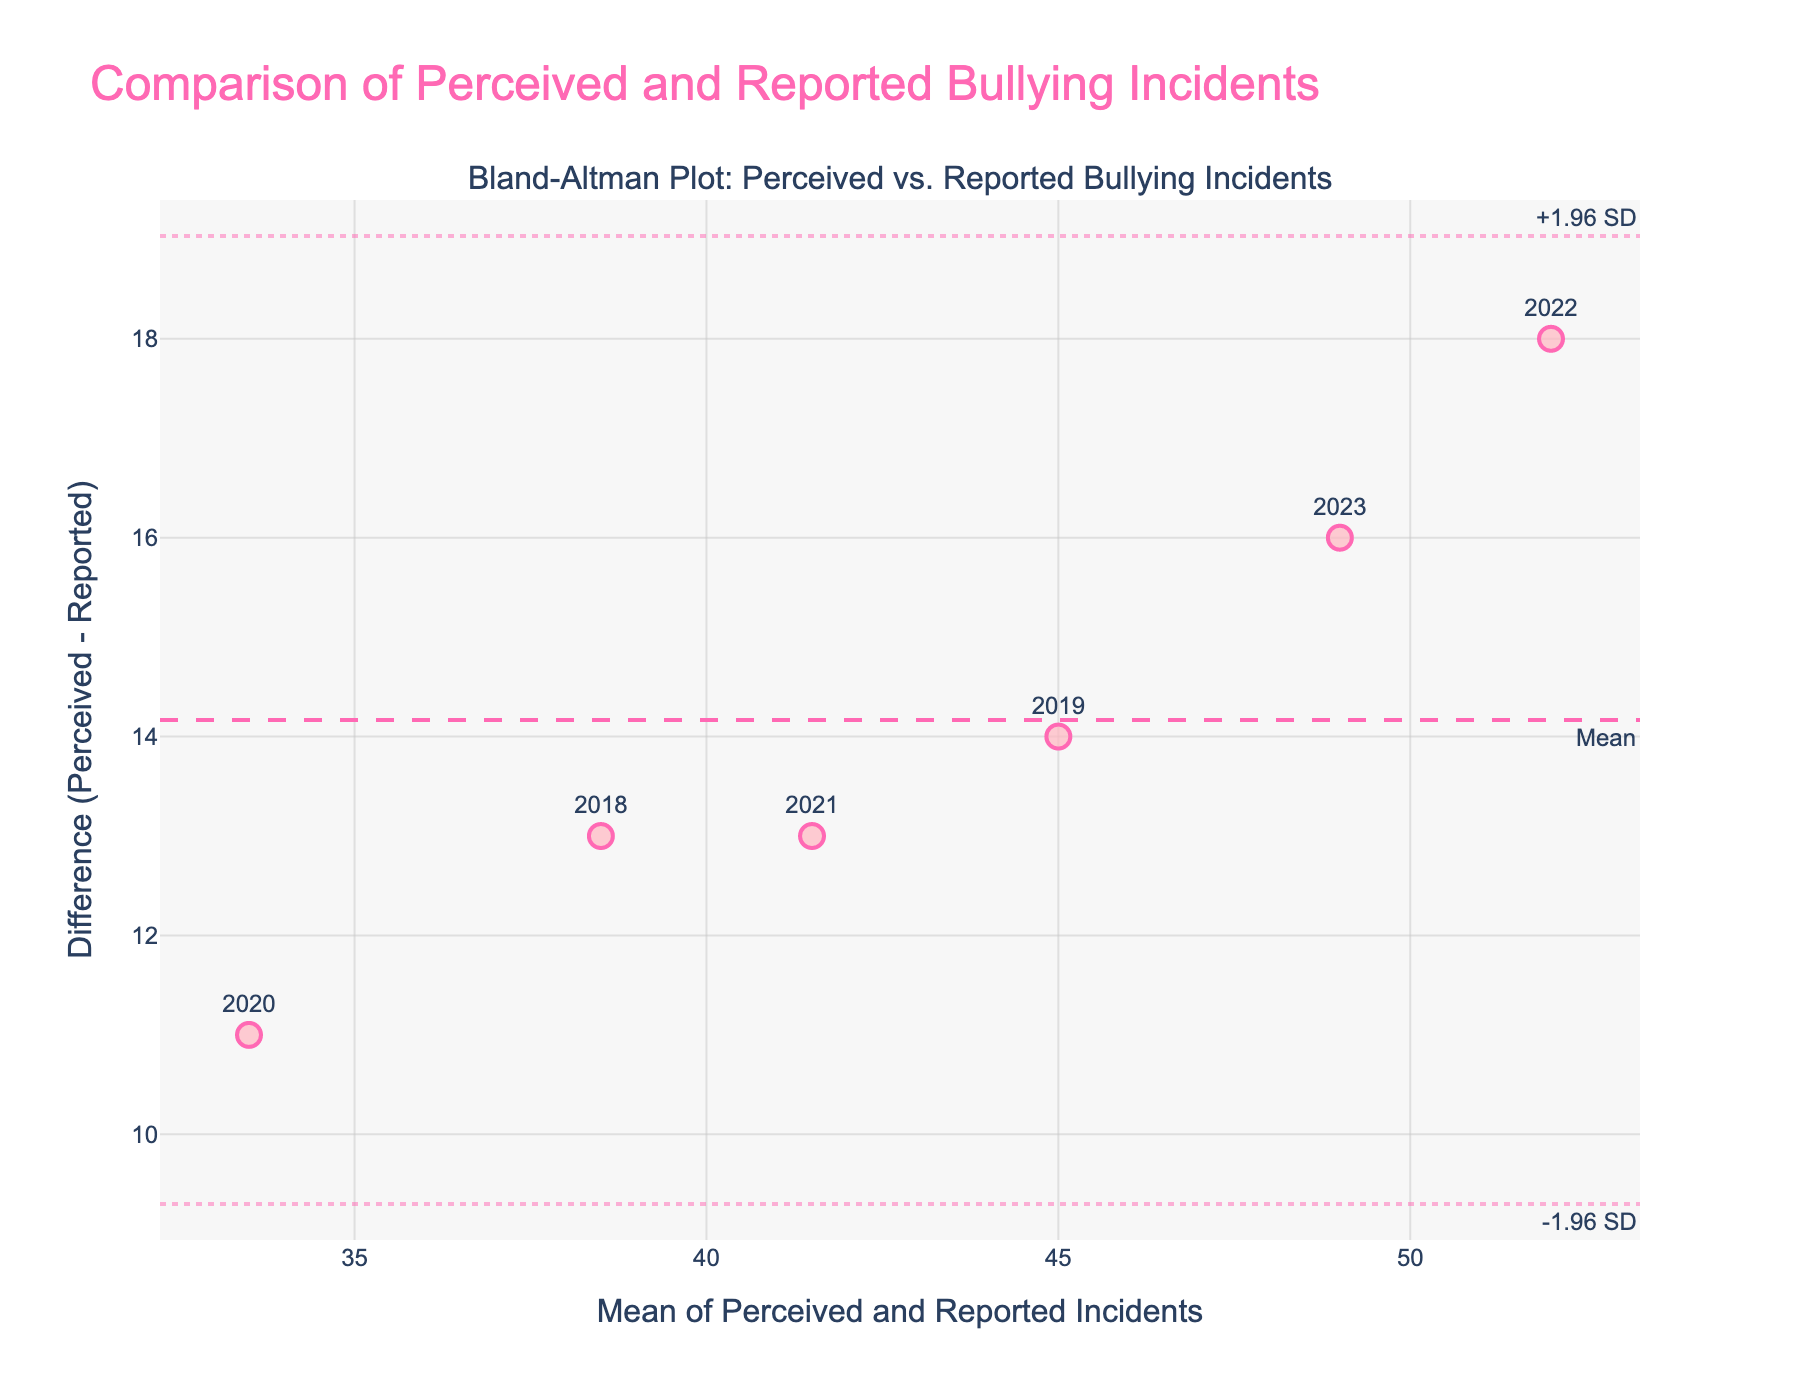How many data points are there on the Bland-Altman plot? There are six data points, one for each school year from 2018 to 2023.
Answer: 6 What is the title of the plot? The title of the plot is located at the top and reads, "Comparison of Perceived and Reported Bullying Incidents".
Answer: Comparison of Perceived and Reported Bullying Incidents What does the x-axis represent in the plot? The x-axis represents the "Mean of Perceived and Reported Incidents".
Answer: Mean of Perceived and Reported Incidents What is the difference between Student_Perceived and Officially_Reported incidents for the year 2022? For 2022, Student_Perceived is 61 and Officially_Reported is 43. The difference is calculated as 61 - 43.
Answer: 18 What is the mean difference line's value on the plot? The mean difference line value is visually represented by the dashed horizontal line labeled "Mean" around 13.5 on the y-axis.
Answer: Approximately 13.5 Which year shows the largest difference between Student_Perceived and Officially_Reported incidents? The year shows the largest difference is identified by finding the point furthest from zero on the y-axis. The point labeled "2022" shows the largest difference.
Answer: 2022 How does the mean difference line compare to the limits of agreement lines? The mean difference line is centered between the two limits of agreement lines. The limits of agreement indicate a range from approximately 4.8 to 22.2.
Answer: Centered Are there any data points that fall outside the limits of agreement? By observing the data points and the limits of agreement lines, all points fall within the range between these lines.
Answer: No Which years have differences closest to the mean difference? Points closest to the mean difference can be identified around the mean difference line, labeled with years 2018, 2021, and 2023.
Answer: 2018, 2021, 2023 